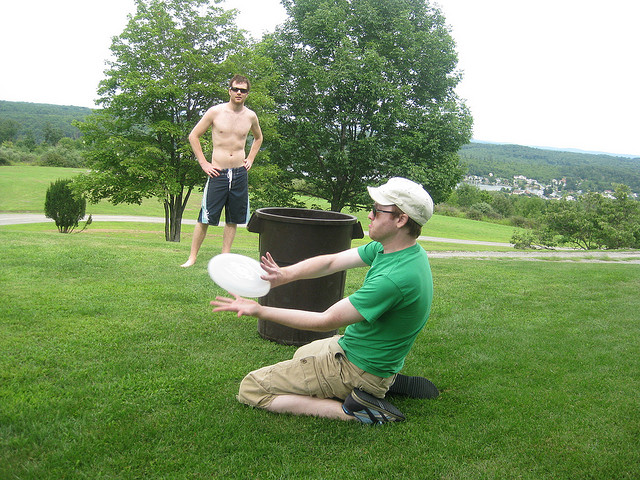How does the activity depicted influence the physical fitness of the participants? Playing frisbee, as seen in the image, positively influences physical fitness by promoting cardiovascular health, enhancing hand-eye coordination, and improving flexibility and balance. It's an aerobic activity that involves running, catching, and throwing, making it a fun and effective workout. 